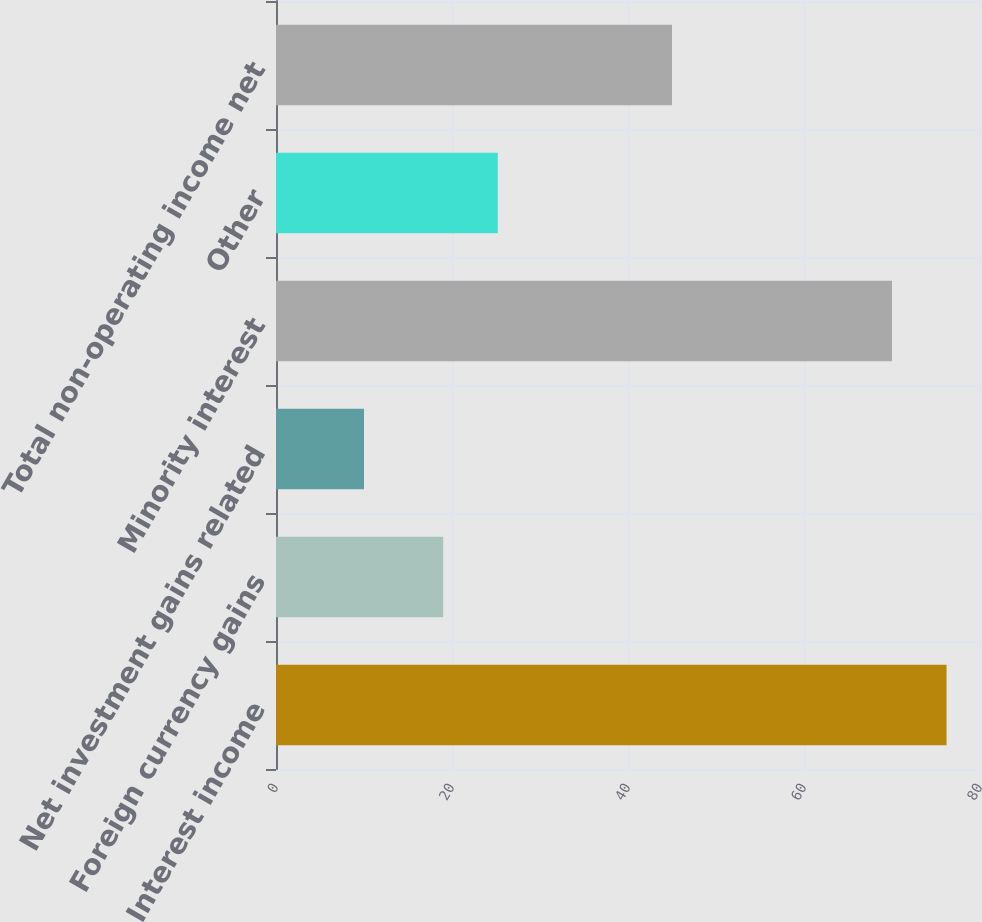<chart> <loc_0><loc_0><loc_500><loc_500><bar_chart><fcel>Interest income<fcel>Foreign currency gains<fcel>Net investment gains related<fcel>Minority interest<fcel>Other<fcel>Total non-operating income net<nl><fcel>76.2<fcel>19<fcel>10<fcel>70<fcel>25.2<fcel>45<nl></chart> 